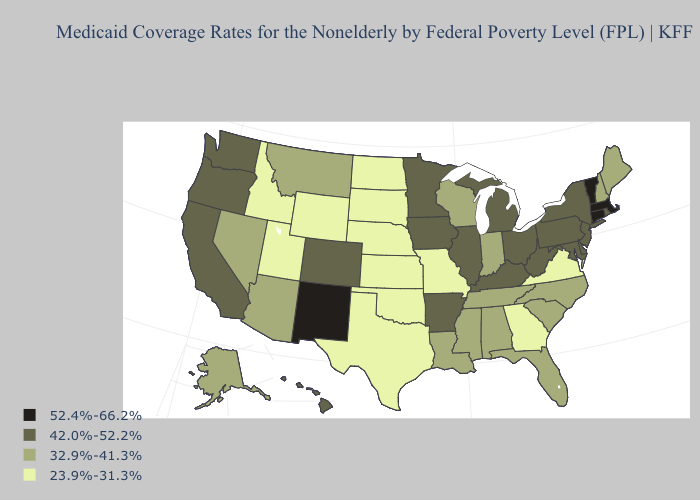Does Hawaii have the lowest value in the West?
Keep it brief. No. Name the states that have a value in the range 42.0%-52.2%?
Quick response, please. Arkansas, California, Colorado, Delaware, Hawaii, Illinois, Iowa, Kentucky, Maryland, Michigan, Minnesota, New Jersey, New York, Ohio, Oregon, Pennsylvania, Rhode Island, Washington, West Virginia. Which states have the lowest value in the MidWest?
Write a very short answer. Kansas, Missouri, Nebraska, North Dakota, South Dakota. What is the value of West Virginia?
Concise answer only. 42.0%-52.2%. What is the value of New Jersey?
Short answer required. 42.0%-52.2%. Does Nevada have the lowest value in the West?
Short answer required. No. Name the states that have a value in the range 52.4%-66.2%?
Concise answer only. Connecticut, Massachusetts, New Mexico, Vermont. What is the value of Hawaii?
Write a very short answer. 42.0%-52.2%. What is the value of Virginia?
Concise answer only. 23.9%-31.3%. Does Iowa have the lowest value in the USA?
Be succinct. No. What is the lowest value in states that border New Mexico?
Quick response, please. 23.9%-31.3%. Name the states that have a value in the range 23.9%-31.3%?
Give a very brief answer. Georgia, Idaho, Kansas, Missouri, Nebraska, North Dakota, Oklahoma, South Dakota, Texas, Utah, Virginia, Wyoming. What is the value of Washington?
Quick response, please. 42.0%-52.2%. Name the states that have a value in the range 23.9%-31.3%?
Short answer required. Georgia, Idaho, Kansas, Missouri, Nebraska, North Dakota, Oklahoma, South Dakota, Texas, Utah, Virginia, Wyoming. 